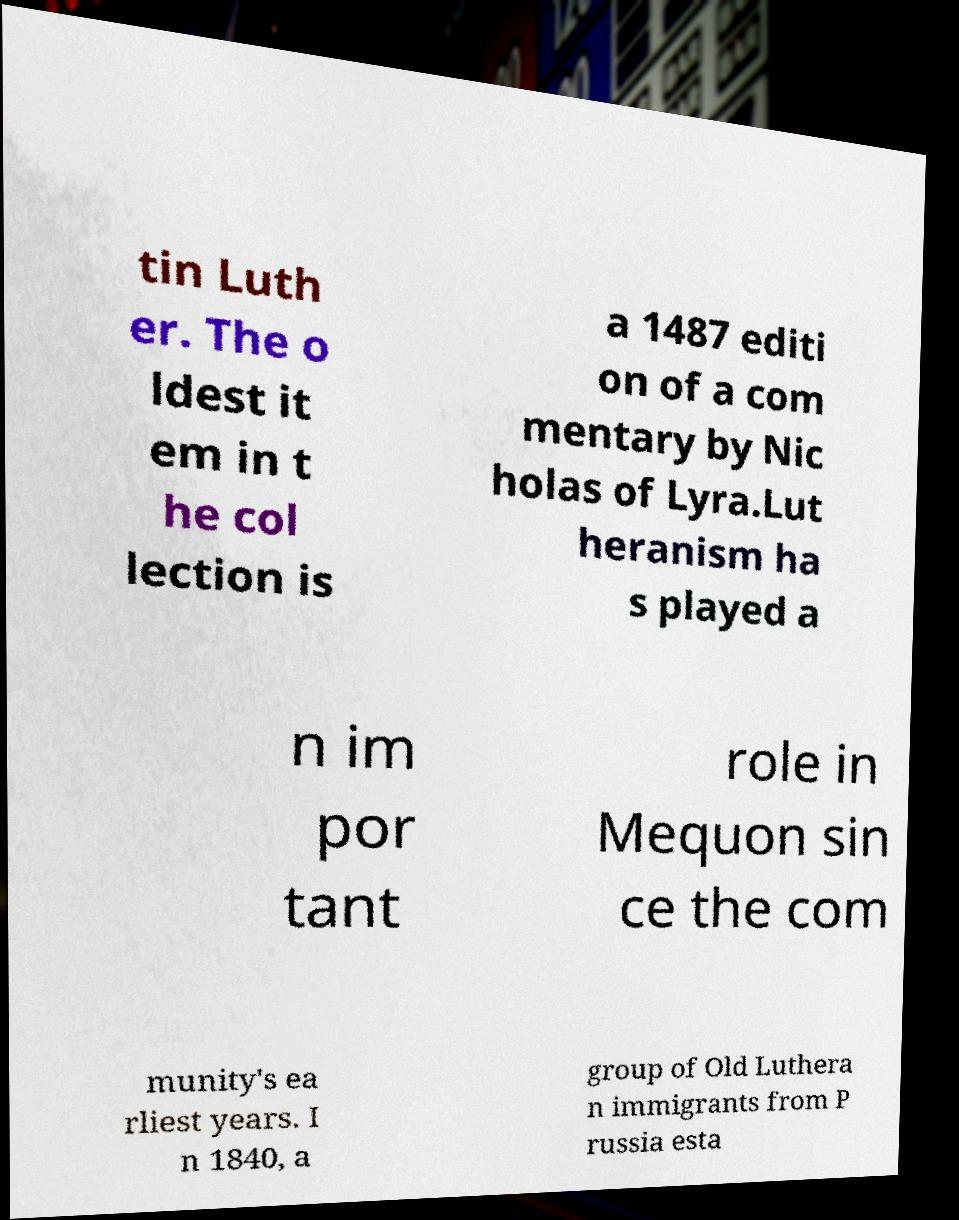I need the written content from this picture converted into text. Can you do that? tin Luth er. The o ldest it em in t he col lection is a 1487 editi on of a com mentary by Nic holas of Lyra.Lut heranism ha s played a n im por tant role in Mequon sin ce the com munity's ea rliest years. I n 1840, a group of Old Luthera n immigrants from P russia esta 